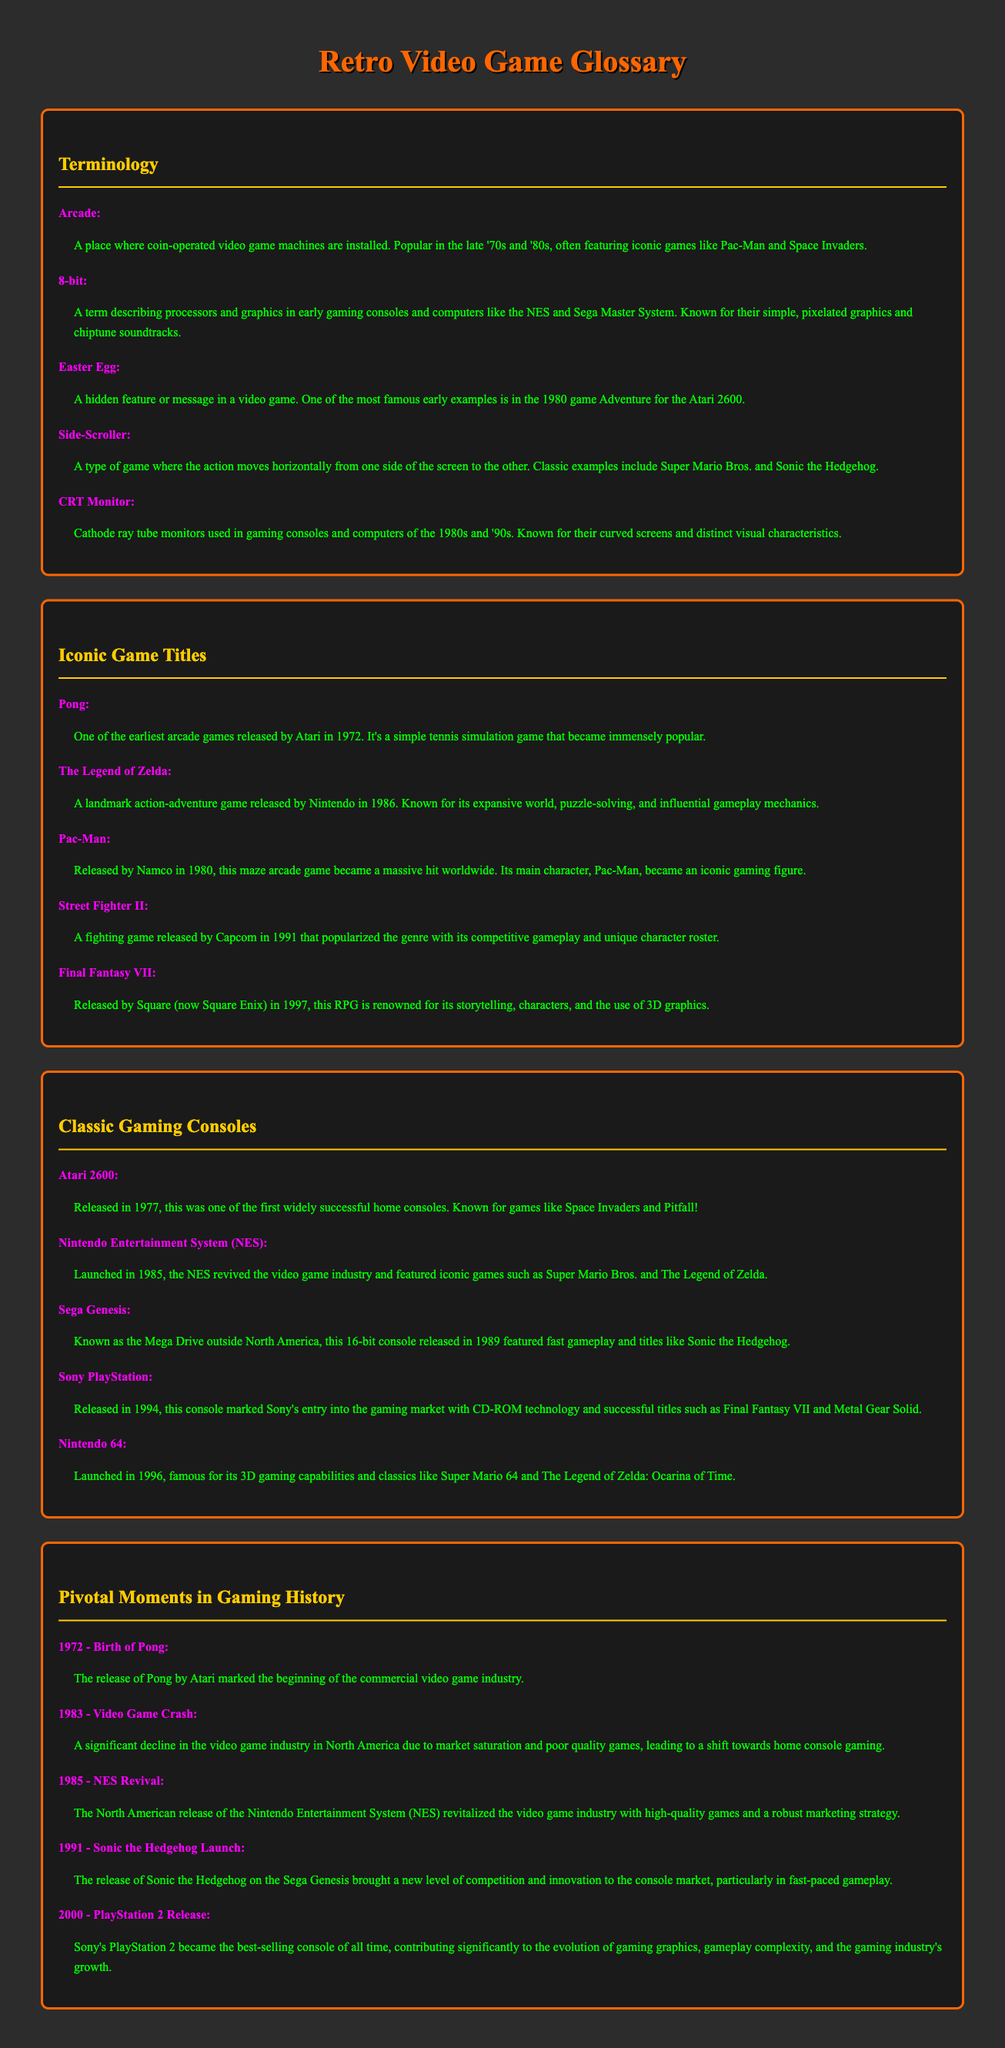What year was Pong released? Pong was released in 1972, which is noted in the Iconic Game Titles section.
Answer: 1972 What does the term "8-bit" refer to? The term "8-bit" describes processors and graphics in early gaming consoles like the NES.
Answer: Processors and graphics Which game is known for its expansive world and puzzle-solving? The Legend of Zelda is recognized for its expansive world and gameplay mechanics in the Iconic Game Titles section.
Answer: The Legend of Zelda What was the main purpose of the Atari 2600? The Atari 2600 was one of the first widely successful home consoles, primarily for gaming.
Answer: Home console gaming What event led to a significant decline in the video game industry in 1983? The video game crash was a pivotal moment that indicated market saturation and poor game quality.
Answer: Video game crash Which console featured Sonic the Hedgehog? Sonic the Hedgehog was featured on the Sega Genesis, as stated in the Classic Gaming Consoles section.
Answer: Sega Genesis What is an "Easter Egg" in video games? An Easter Egg is a hidden feature or message within a game, with an example in the document.
Answer: Hidden feature or message Which gaming console marked Sony's entry into the market? The Sony PlayStation marked Sony's entry with CD-ROM technology and notable game titles.
Answer: Sony PlayStation In what year was the Nintendo Entertainment System released? The NES was launched in 1985, which is specified in the Classic Gaming Consoles section.
Answer: 1985 